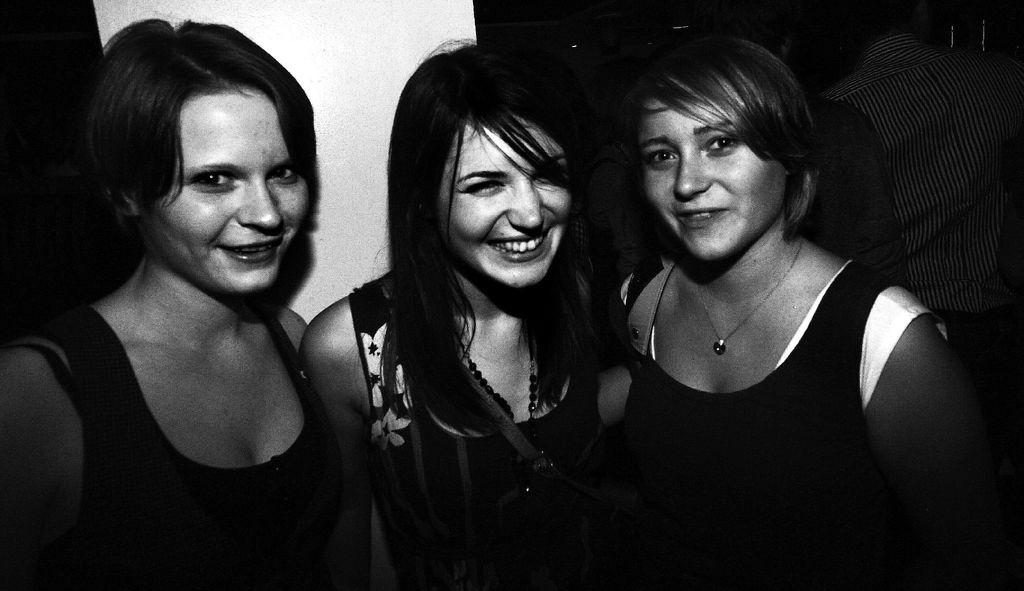What is the color scheme of the image? The image is black and white. Who are the main subjects in the image? There are three girls in the center of the image. What can be seen in the background of the image? There is a wall in the background of the image. How many people are present in the image? There are people present in the image. What type of memory is being used by the girls in the image? There is no indication of any memory being used in the image; it simply features three girls in a black and white setting. What appliance can be seen on the wall in the image? There is no appliance visible on the wall in the image; only a wall is present in the background. 